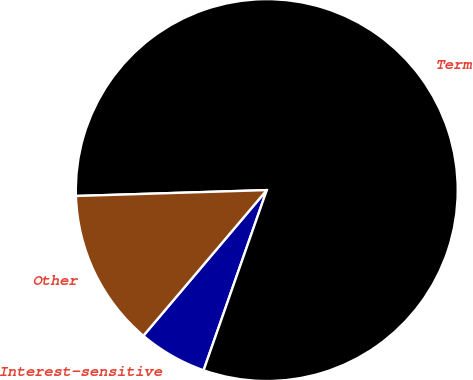<chart> <loc_0><loc_0><loc_500><loc_500><pie_chart><fcel>Interest-sensitive<fcel>Term<fcel>Other<nl><fcel>5.82%<fcel>80.85%<fcel>13.32%<nl></chart> 